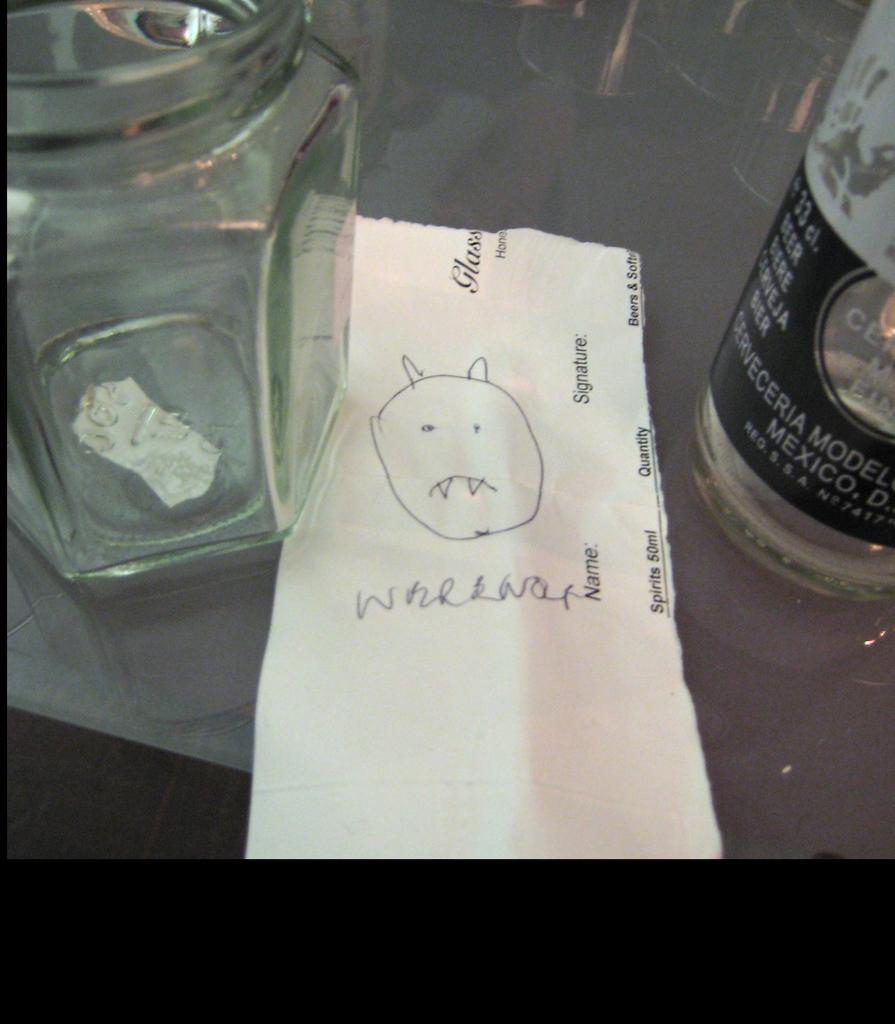What is located on the left side of the image? There is a jar on the left side of the image. What is on the opposite side of the image? There is a bottle on the right side of the image. What is in the middle of the image? There is a paper in the middle of the image. What can be seen on the paper? There are doodles on the paper. How many kittens are playing with the doodles on the paper? There are no kittens present in the image; it only features a jar, a bottle, a paper, and doodles. What type of shock can be seen in the image? There is no shock present in the image; it only features a jar, a bottle, a paper, and doodles. 